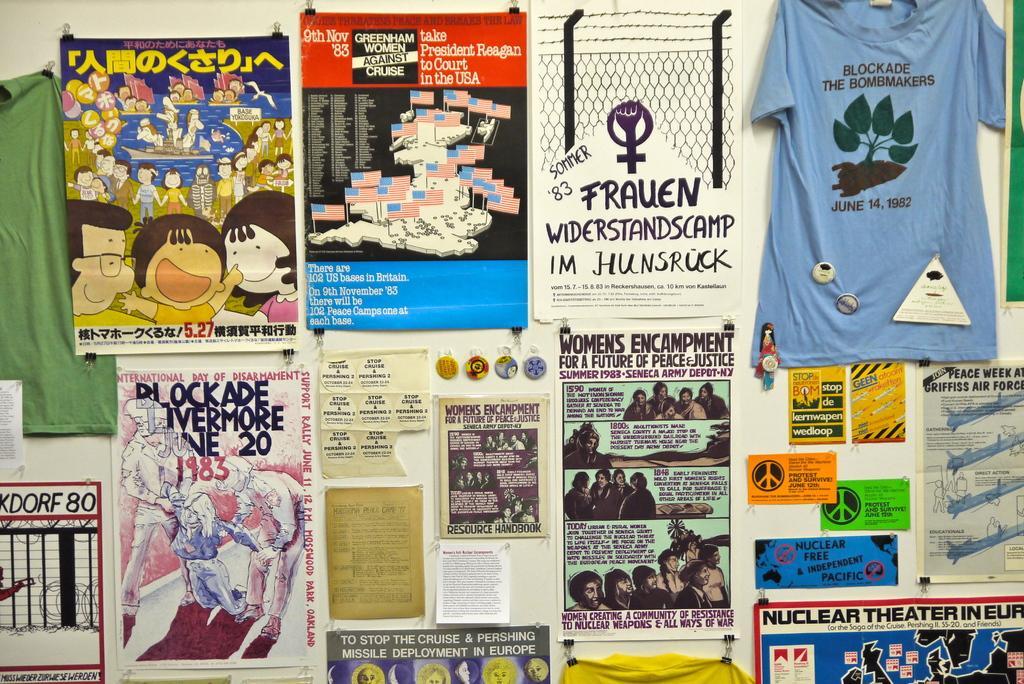How would you summarize this image in a sentence or two? In this picture there is a wall. On the wall there are some books, hoardings, charts and t shirts, cards. 